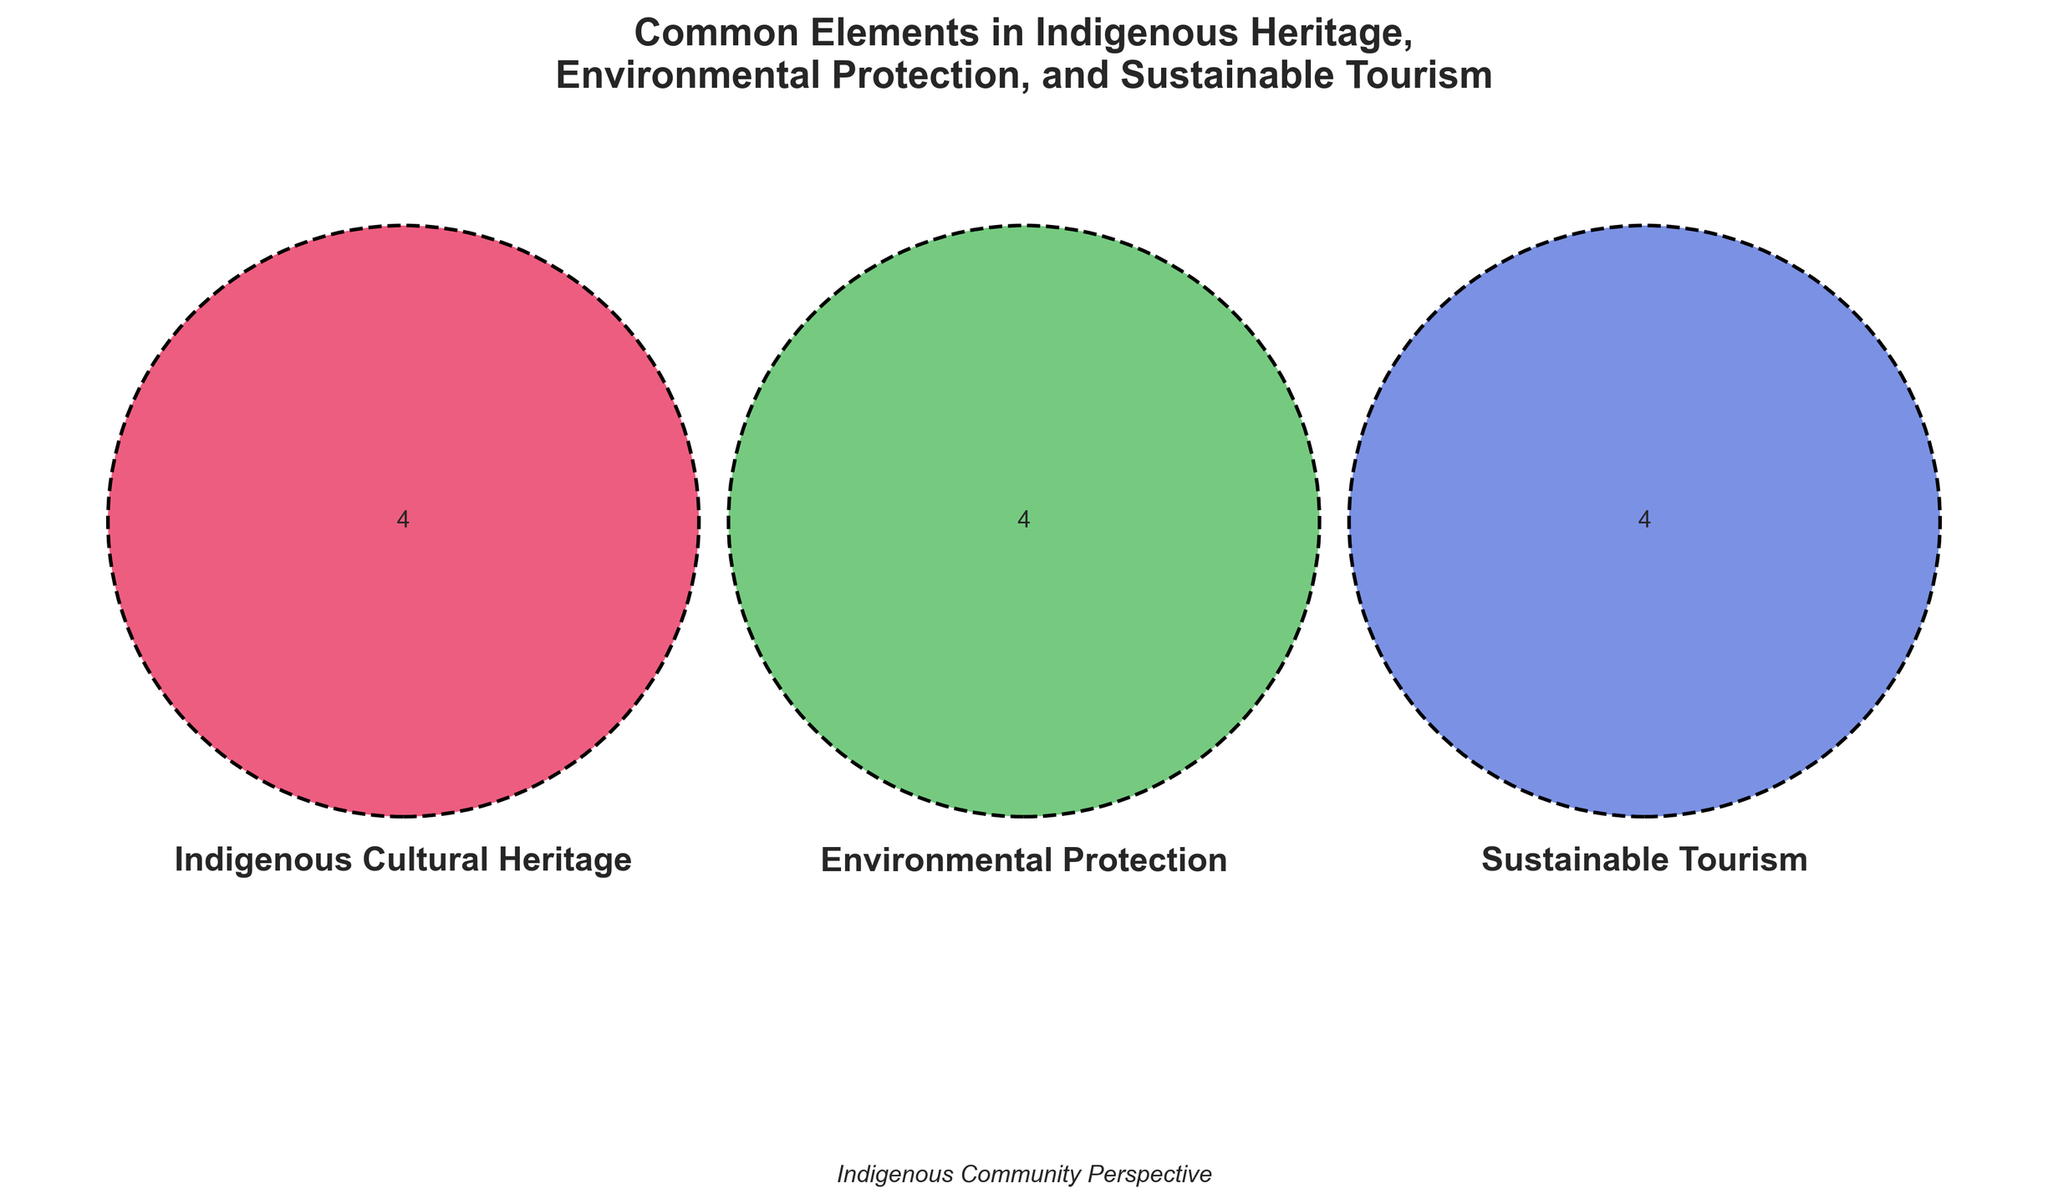What is the title of the Venn diagram? The title of the Venn diagram is generally displayed at the top. In the rendered figure, the title reads "Common Elements in Indigenous Heritage, Environmental Protection, and Sustainable Tourism".
Answer: "Common Elements in Indigenous Heritage, Environmental Protection, and Sustainable Tourism" How many sets are represented in the Venn diagram? A Venn diagram with three overlapping circles represents three sets. These sets typically overlap in various ways to show commonalities between them.
Answer: 3 Which element is common to all three categories: Indigenous Cultural Heritage, Environmental Protection, and Sustainable Tourism? The center-most section of the Venn diagram, where all three circles overlap, represents the shared elements among the three categories. In this case, "Coffee production" is in the center.
Answer: Coffee production What colors are used to represent each category? The colors used in the Venn diagram help differentiate between the three sets. The category Indigenous Cultural Heritage is in red, Environmental Protection is in green, and Sustainable Tourism is in blue, as indicated by the circles' colors.
Answer: Red, Green, Blue Name an element common to both Indigenous Cultural Heritage and Environmental Protection but not Sustainable Tourism? The section where the red and green circles overlap but exclude the blue circle shows common elements between Indigenous Cultural Heritage and Environmental Protection. "Watershed management" appears in this section.
Answer: Watershed management Which categories include "Traditional farming methods"? To find which categories include "Traditional farming methods," locate this text within the Venn diagram. It appears in the center-most section where all three circles overlap.
Answer: Indigenous Cultural Heritage, Environmental Protection, and Sustainable Tourism List all elements unique to Indigenous Cultural Heritage. Unique elements for Indigenous Cultural Heritage appear in the portion of the red circle that does not overlap with the green and blue circles. These elements are: "Traditional ceremonies," "Ancestral languages," "Oral histories," and "Traditional dress."
Answer: Traditional ceremonies, Ancestral languages, Oral histories, Traditional dress Which category has more unique elements, Indigenous Cultural Heritage, or Sustainable Tourism? Compare the unique sections of both the Indigenous Cultural Heritage and Sustainable Tourism circles. Indigenous Cultural Heritage has four unique elements, while Sustainable Tourism has three unique elements.
Answer: Indigenous Cultural Heritage What overlaps exist between Sustainable Tourism and each of the other categories? To determine which elements are common between Sustainable Tourism and each of the other categories, look at the overlapping regions. The overlap between Sustainable Tourism and Indigenous Cultural Heritage includes "Cultural tours" and "Artisan markets." Overlapping with Environmental Protection includes "Eco-lodges" and "Home stays."
Answer: Cultural tours, Artisan markets; Eco-lodges, Home stays What is found uniquely within Environmental Protection? Elements uniquely found in Environmental Protection appear within the section of the green circle that does not overlap with either the red or blue circles. "Forest conservation," "Biodiversity preservation," "Watershed management," and "Soil conservation" are listed here.
Answer: Forest conservation, Biodiversity preservation, Watershed management, Soil conservation 